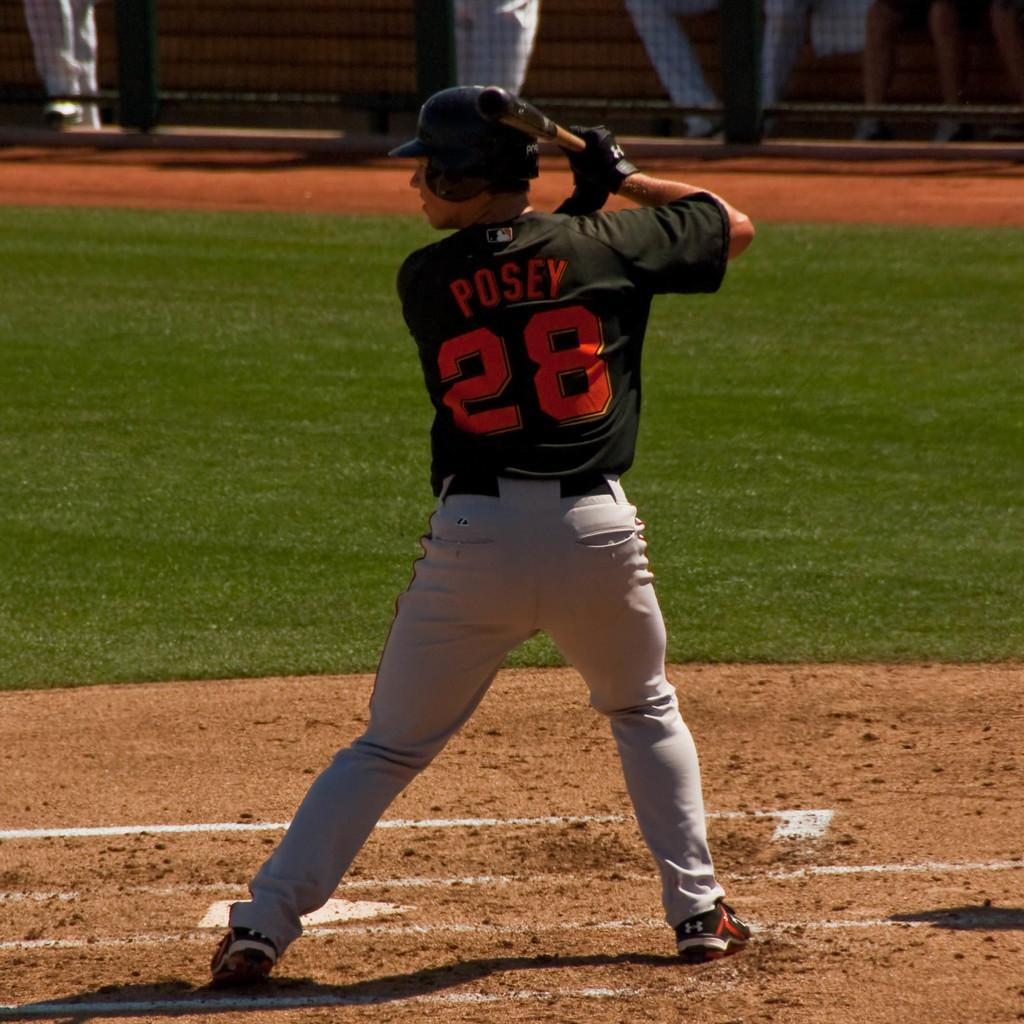<image>
Describe the image concisely. Player Posey number 28 gets ready to hit the ball with the bat. 